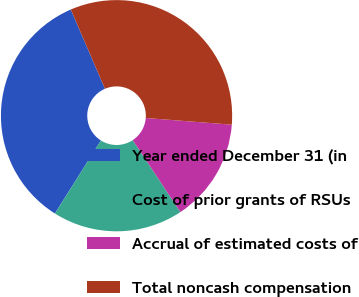<chart> <loc_0><loc_0><loc_500><loc_500><pie_chart><fcel>Year ended December 31 (in<fcel>Cost of prior grants of RSUs<fcel>Accrual of estimated costs of<fcel>Total noncash compensation<nl><fcel>34.58%<fcel>18.26%<fcel>14.45%<fcel>32.71%<nl></chart> 